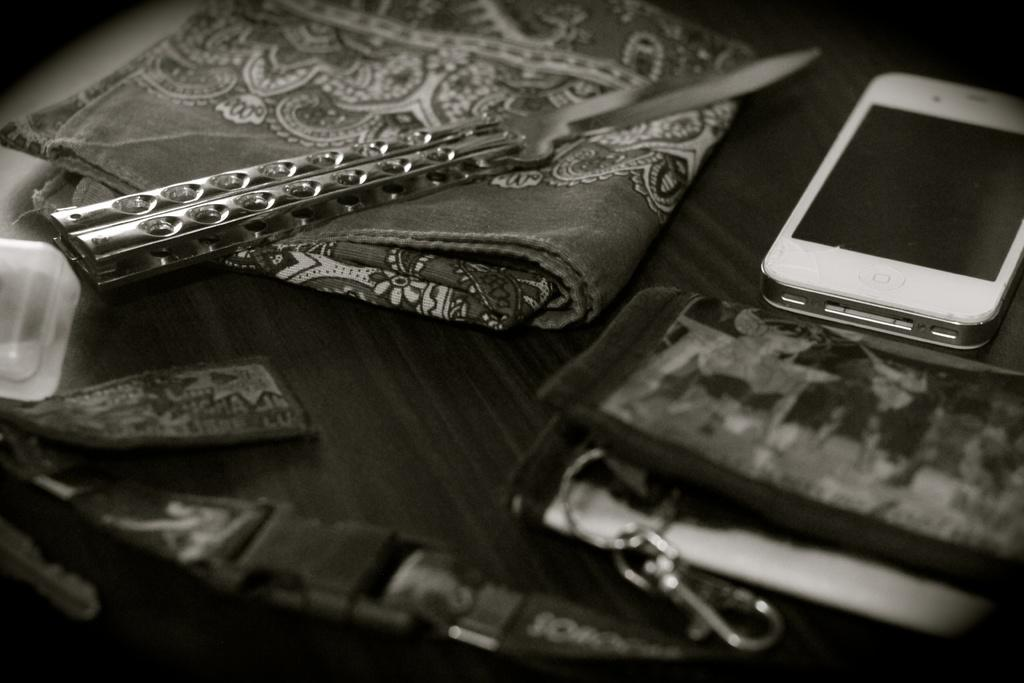What electronic device is visible in the image? There is a cell phone in the image. What personal item is present in the image? There is a handkerchief in the image. What sharp object can be seen in the image? There is a knife in the image. What type of container is in the image? There is a bag in the image. Where are all the objects located in the image? All objects are on a table. What type of zipper is used to close the bag in the image? There is no mention of a zipper in the image; the bag's closure method is not specified. What is the current temperature in the image? The image does not provide any information about the temperature; it only shows objects on a table. 